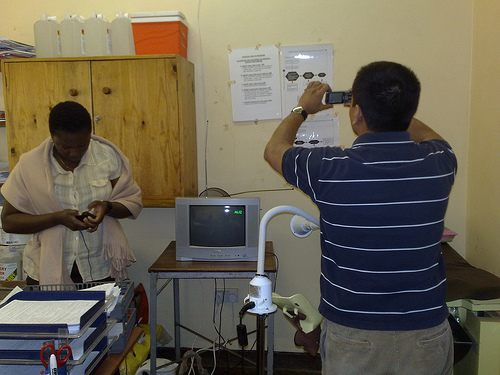<image>
Is the cellphone behind the man? No. The cellphone is not behind the man. From this viewpoint, the cellphone appears to be positioned elsewhere in the scene. 